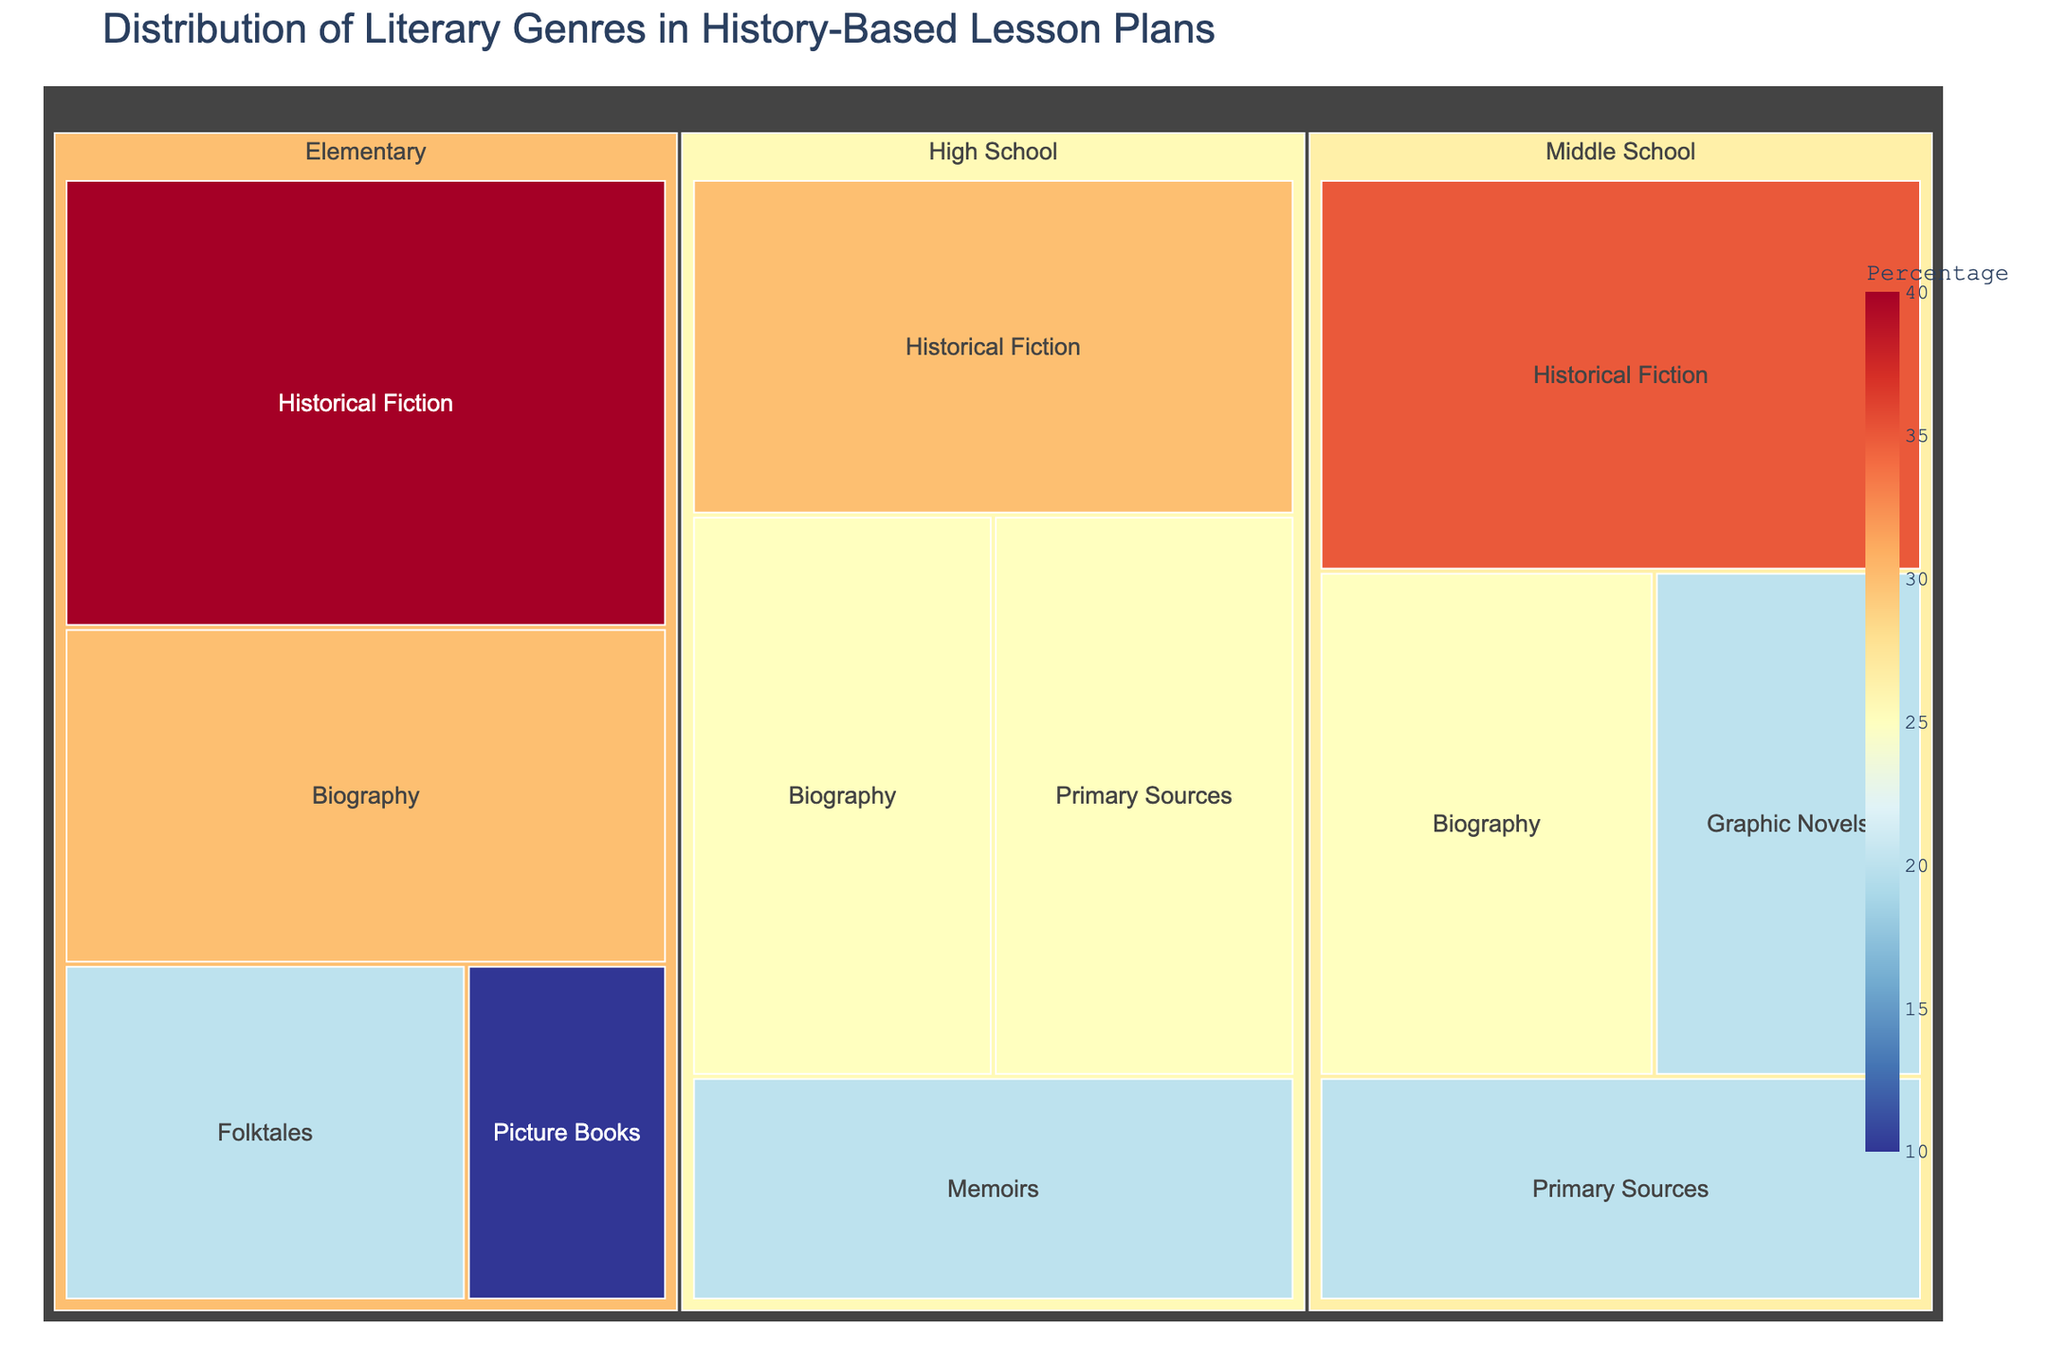What percentage of the genres used in Elementary grade are Historical Fiction? The treemap shows the distribution of literary genres by grade level. In the Elementary grade segment, Historical Fiction takes up 40%.
Answer: 40% Which grade level uses the highest percentage of Memoirs? Memoirs are only shown in the High School section with a percentage of 20%. No other grade levels include Memoirs.
Answer: High School What is the total percentage of Biography genres used across all grade levels? Summing the percentages of Biography across Elementary, Middle School, and High School: 30% + 25% + 25% = 80%
Answer: 80% Compare the percentage usage of Historical Fiction between Middle School and High School. Which one uses more and by how much? Middle School uses 35% of Historical Fiction, while High School uses 30%. The difference is 35% - 30% = 5%.
Answer: Middle School by 5% Which genre appears in the Middle School but not in the Elementary grade? The treemap shows that Graphic Novels and Primary Sources appear in Middle School but not in Elementary.
Answer: Graphic Novels, Primary Sources How does the percentage of Folktales in Elementary grade compare to Primary Sources in the Middle School grade? Folktales in Elementary grade have a percentage of 20%, whereas Primary Sources in Middle School also have 20%. They are equal.
Answer: Equal What is the most commonly used genre in High School lesson plans? The most dominant segment in the High School section of the treemap is Historical Fiction, with a percentage of 30%.
Answer: Historical Fiction Calculate the difference in usage percentage of Historical Fiction between Elementary and High School levels. Historical Fiction is used 40% in Elementary and 30% in High School. The difference is 40% - 30% = 10%.
Answer: 10% Which grade level uses the most diverse range of genres according to the treemap? The treemap shows four different genres for each grade level, so they are equally diverse in this context.
Answer: All equally diverse 